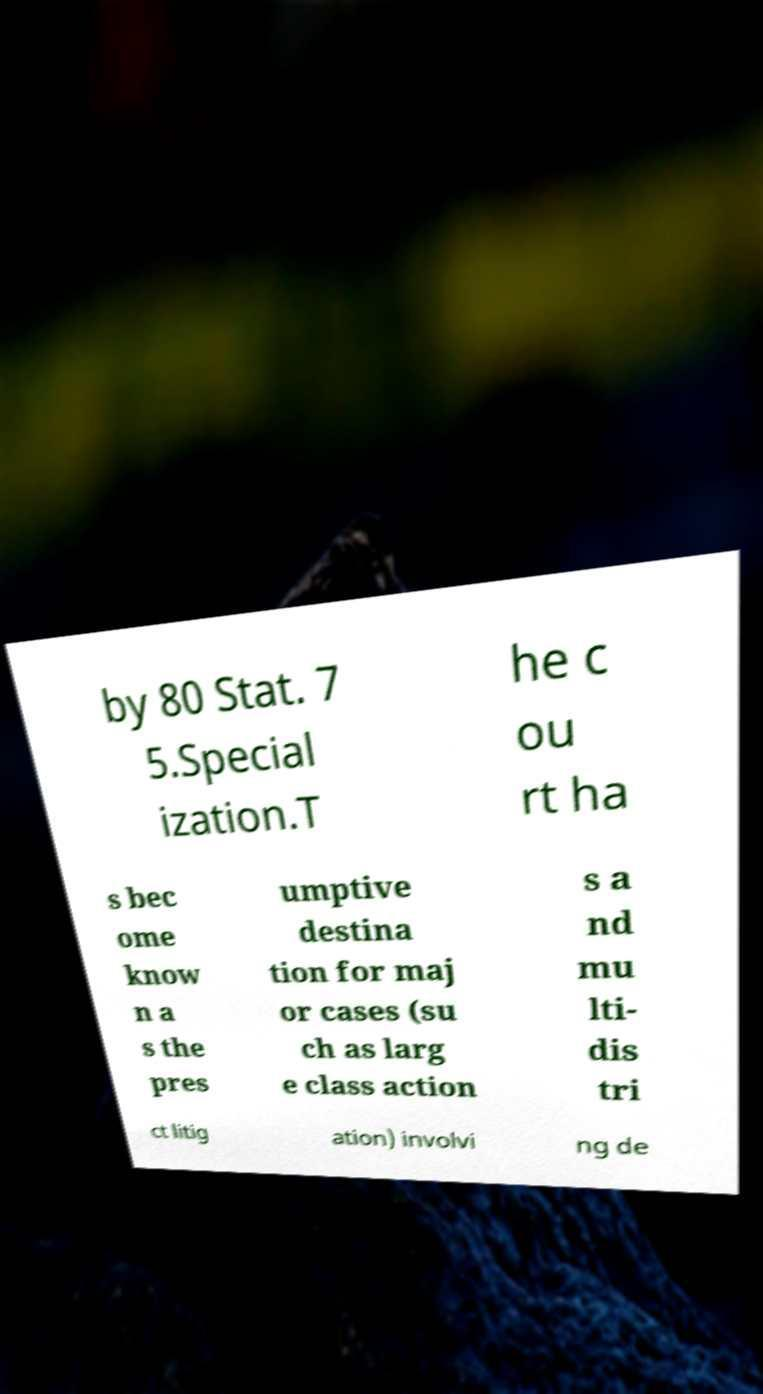Can you accurately transcribe the text from the provided image for me? by 80 Stat. 7 5.Special ization.T he c ou rt ha s bec ome know n a s the pres umptive destina tion for maj or cases (su ch as larg e class action s a nd mu lti- dis tri ct litig ation) involvi ng de 